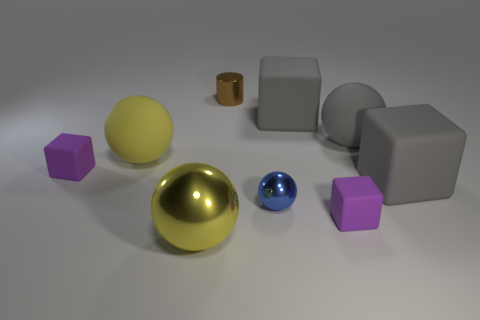There is a purple object that is to the left of the tiny brown cylinder; what is its material?
Offer a terse response. Rubber. How big is the brown thing that is behind the yellow ball that is behind the tiny rubber cube on the right side of the blue thing?
Provide a succinct answer. Small. There is a gray rubber sphere; is it the same size as the metal sphere that is to the left of the tiny brown object?
Offer a terse response. Yes. The block on the left side of the small cylinder is what color?
Make the answer very short. Purple. What is the shape of the matte thing that is the same color as the big shiny thing?
Keep it short and to the point. Sphere. The object that is on the left side of the large yellow matte sphere has what shape?
Ensure brevity in your answer.  Cube. What number of blue objects are tiny shiny spheres or tiny metal things?
Your answer should be very brief. 1. Does the blue sphere have the same material as the brown object?
Make the answer very short. Yes. There is a tiny blue metallic object; how many tiny brown objects are in front of it?
Offer a terse response. 0. What is the small thing that is to the right of the large metallic thing and behind the tiny blue metal object made of?
Your answer should be compact. Metal. 